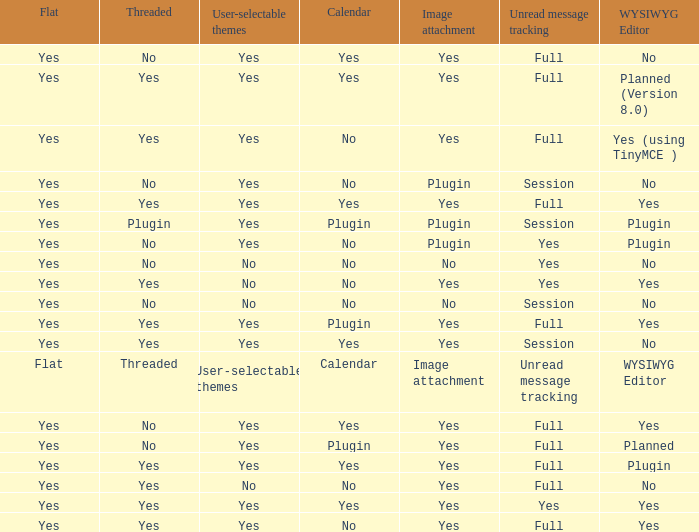Which Calendar has a WYSIWYG Editor of no, and an Unread message tracking of session, and an Image attachment of no? No. 